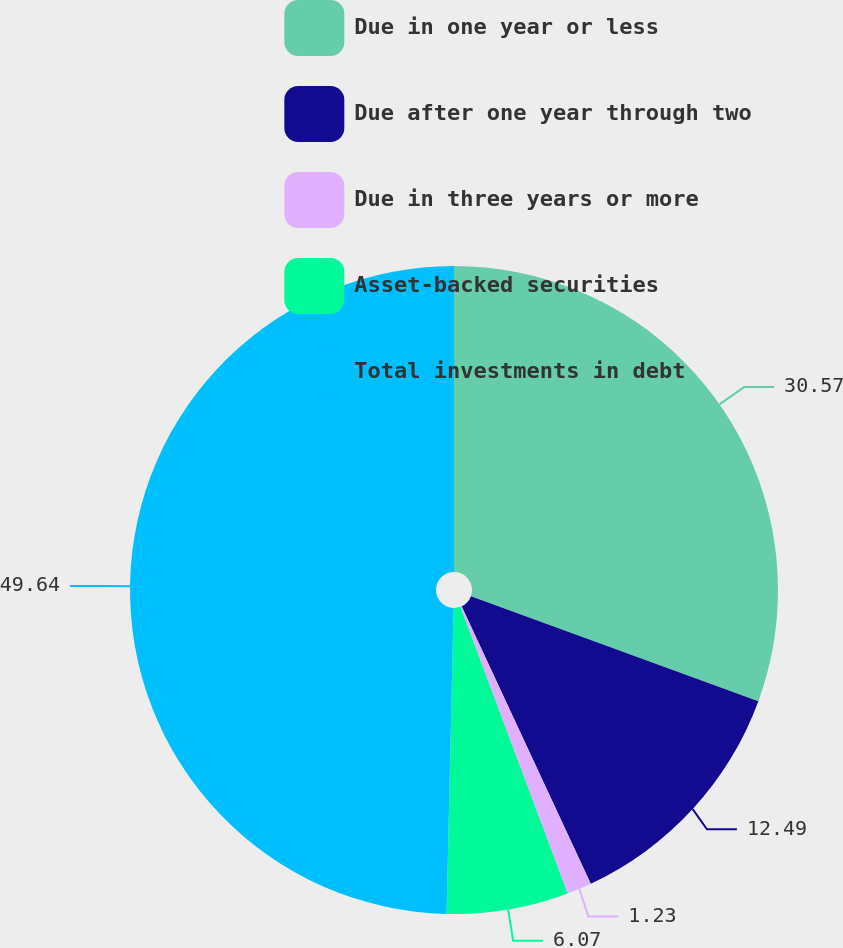<chart> <loc_0><loc_0><loc_500><loc_500><pie_chart><fcel>Due in one year or less<fcel>Due after one year through two<fcel>Due in three years or more<fcel>Asset-backed securities<fcel>Total investments in debt<nl><fcel>30.57%<fcel>12.49%<fcel>1.23%<fcel>6.07%<fcel>49.63%<nl></chart> 